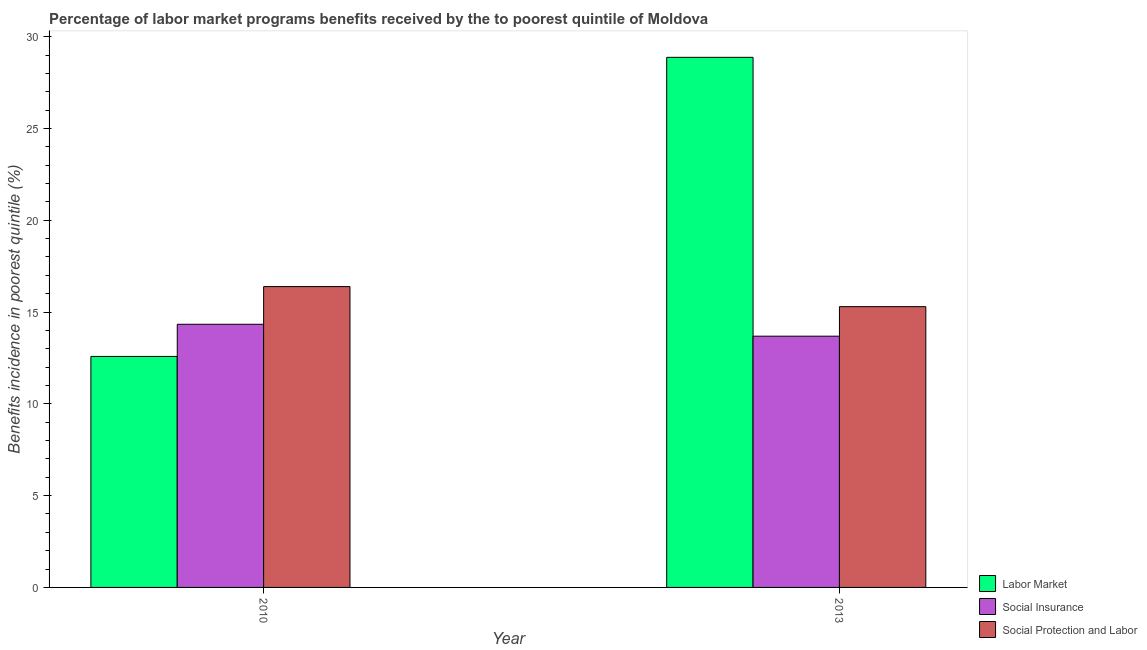Are the number of bars per tick equal to the number of legend labels?
Provide a short and direct response. Yes. Are the number of bars on each tick of the X-axis equal?
Offer a very short reply. Yes. How many bars are there on the 2nd tick from the left?
Give a very brief answer. 3. How many bars are there on the 1st tick from the right?
Your answer should be compact. 3. What is the label of the 1st group of bars from the left?
Make the answer very short. 2010. In how many cases, is the number of bars for a given year not equal to the number of legend labels?
Offer a very short reply. 0. What is the percentage of benefits received due to labor market programs in 2010?
Offer a terse response. 12.58. Across all years, what is the maximum percentage of benefits received due to social insurance programs?
Your answer should be very brief. 14.33. Across all years, what is the minimum percentage of benefits received due to social protection programs?
Offer a terse response. 15.29. In which year was the percentage of benefits received due to social insurance programs maximum?
Provide a short and direct response. 2010. What is the total percentage of benefits received due to social protection programs in the graph?
Provide a succinct answer. 31.68. What is the difference between the percentage of benefits received due to social protection programs in 2010 and that in 2013?
Your answer should be compact. 1.09. What is the difference between the percentage of benefits received due to labor market programs in 2010 and the percentage of benefits received due to social protection programs in 2013?
Offer a very short reply. -16.29. What is the average percentage of benefits received due to labor market programs per year?
Keep it short and to the point. 20.73. What is the ratio of the percentage of benefits received due to labor market programs in 2010 to that in 2013?
Offer a terse response. 0.44. What does the 1st bar from the left in 2013 represents?
Your answer should be compact. Labor Market. What does the 3rd bar from the right in 2013 represents?
Your response must be concise. Labor Market. How many years are there in the graph?
Your response must be concise. 2. What is the difference between two consecutive major ticks on the Y-axis?
Your answer should be very brief. 5. Are the values on the major ticks of Y-axis written in scientific E-notation?
Provide a succinct answer. No. Does the graph contain grids?
Keep it short and to the point. No. Where does the legend appear in the graph?
Your answer should be compact. Bottom right. How many legend labels are there?
Keep it short and to the point. 3. How are the legend labels stacked?
Give a very brief answer. Vertical. What is the title of the graph?
Keep it short and to the point. Percentage of labor market programs benefits received by the to poorest quintile of Moldova. What is the label or title of the Y-axis?
Keep it short and to the point. Benefits incidence in poorest quintile (%). What is the Benefits incidence in poorest quintile (%) in Labor Market in 2010?
Keep it short and to the point. 12.58. What is the Benefits incidence in poorest quintile (%) in Social Insurance in 2010?
Your response must be concise. 14.33. What is the Benefits incidence in poorest quintile (%) of Social Protection and Labor in 2010?
Keep it short and to the point. 16.39. What is the Benefits incidence in poorest quintile (%) in Labor Market in 2013?
Offer a terse response. 28.88. What is the Benefits incidence in poorest quintile (%) of Social Insurance in 2013?
Provide a succinct answer. 13.69. What is the Benefits incidence in poorest quintile (%) of Social Protection and Labor in 2013?
Your response must be concise. 15.29. Across all years, what is the maximum Benefits incidence in poorest quintile (%) of Labor Market?
Offer a very short reply. 28.88. Across all years, what is the maximum Benefits incidence in poorest quintile (%) in Social Insurance?
Keep it short and to the point. 14.33. Across all years, what is the maximum Benefits incidence in poorest quintile (%) in Social Protection and Labor?
Make the answer very short. 16.39. Across all years, what is the minimum Benefits incidence in poorest quintile (%) in Labor Market?
Provide a short and direct response. 12.58. Across all years, what is the minimum Benefits incidence in poorest quintile (%) in Social Insurance?
Your response must be concise. 13.69. Across all years, what is the minimum Benefits incidence in poorest quintile (%) of Social Protection and Labor?
Provide a succinct answer. 15.29. What is the total Benefits incidence in poorest quintile (%) in Labor Market in the graph?
Keep it short and to the point. 41.46. What is the total Benefits incidence in poorest quintile (%) in Social Insurance in the graph?
Offer a very short reply. 28.02. What is the total Benefits incidence in poorest quintile (%) in Social Protection and Labor in the graph?
Ensure brevity in your answer.  31.68. What is the difference between the Benefits incidence in poorest quintile (%) in Labor Market in 2010 and that in 2013?
Provide a succinct answer. -16.29. What is the difference between the Benefits incidence in poorest quintile (%) of Social Insurance in 2010 and that in 2013?
Provide a succinct answer. 0.65. What is the difference between the Benefits incidence in poorest quintile (%) of Social Protection and Labor in 2010 and that in 2013?
Your answer should be very brief. 1.09. What is the difference between the Benefits incidence in poorest quintile (%) of Labor Market in 2010 and the Benefits incidence in poorest quintile (%) of Social Insurance in 2013?
Your answer should be compact. -1.1. What is the difference between the Benefits incidence in poorest quintile (%) of Labor Market in 2010 and the Benefits incidence in poorest quintile (%) of Social Protection and Labor in 2013?
Give a very brief answer. -2.71. What is the difference between the Benefits incidence in poorest quintile (%) in Social Insurance in 2010 and the Benefits incidence in poorest quintile (%) in Social Protection and Labor in 2013?
Ensure brevity in your answer.  -0.96. What is the average Benefits incidence in poorest quintile (%) in Labor Market per year?
Offer a very short reply. 20.73. What is the average Benefits incidence in poorest quintile (%) in Social Insurance per year?
Your response must be concise. 14.01. What is the average Benefits incidence in poorest quintile (%) in Social Protection and Labor per year?
Provide a succinct answer. 15.84. In the year 2010, what is the difference between the Benefits incidence in poorest quintile (%) of Labor Market and Benefits incidence in poorest quintile (%) of Social Insurance?
Make the answer very short. -1.75. In the year 2010, what is the difference between the Benefits incidence in poorest quintile (%) of Labor Market and Benefits incidence in poorest quintile (%) of Social Protection and Labor?
Offer a terse response. -3.8. In the year 2010, what is the difference between the Benefits incidence in poorest quintile (%) in Social Insurance and Benefits incidence in poorest quintile (%) in Social Protection and Labor?
Make the answer very short. -2.05. In the year 2013, what is the difference between the Benefits incidence in poorest quintile (%) in Labor Market and Benefits incidence in poorest quintile (%) in Social Insurance?
Give a very brief answer. 15.19. In the year 2013, what is the difference between the Benefits incidence in poorest quintile (%) in Labor Market and Benefits incidence in poorest quintile (%) in Social Protection and Labor?
Your response must be concise. 13.58. In the year 2013, what is the difference between the Benefits incidence in poorest quintile (%) in Social Insurance and Benefits incidence in poorest quintile (%) in Social Protection and Labor?
Your answer should be very brief. -1.61. What is the ratio of the Benefits incidence in poorest quintile (%) of Labor Market in 2010 to that in 2013?
Make the answer very short. 0.44. What is the ratio of the Benefits incidence in poorest quintile (%) of Social Insurance in 2010 to that in 2013?
Provide a succinct answer. 1.05. What is the ratio of the Benefits incidence in poorest quintile (%) of Social Protection and Labor in 2010 to that in 2013?
Ensure brevity in your answer.  1.07. What is the difference between the highest and the second highest Benefits incidence in poorest quintile (%) of Labor Market?
Offer a terse response. 16.29. What is the difference between the highest and the second highest Benefits incidence in poorest quintile (%) of Social Insurance?
Your answer should be compact. 0.65. What is the difference between the highest and the second highest Benefits incidence in poorest quintile (%) in Social Protection and Labor?
Make the answer very short. 1.09. What is the difference between the highest and the lowest Benefits incidence in poorest quintile (%) in Labor Market?
Offer a terse response. 16.29. What is the difference between the highest and the lowest Benefits incidence in poorest quintile (%) in Social Insurance?
Your answer should be compact. 0.65. What is the difference between the highest and the lowest Benefits incidence in poorest quintile (%) of Social Protection and Labor?
Ensure brevity in your answer.  1.09. 